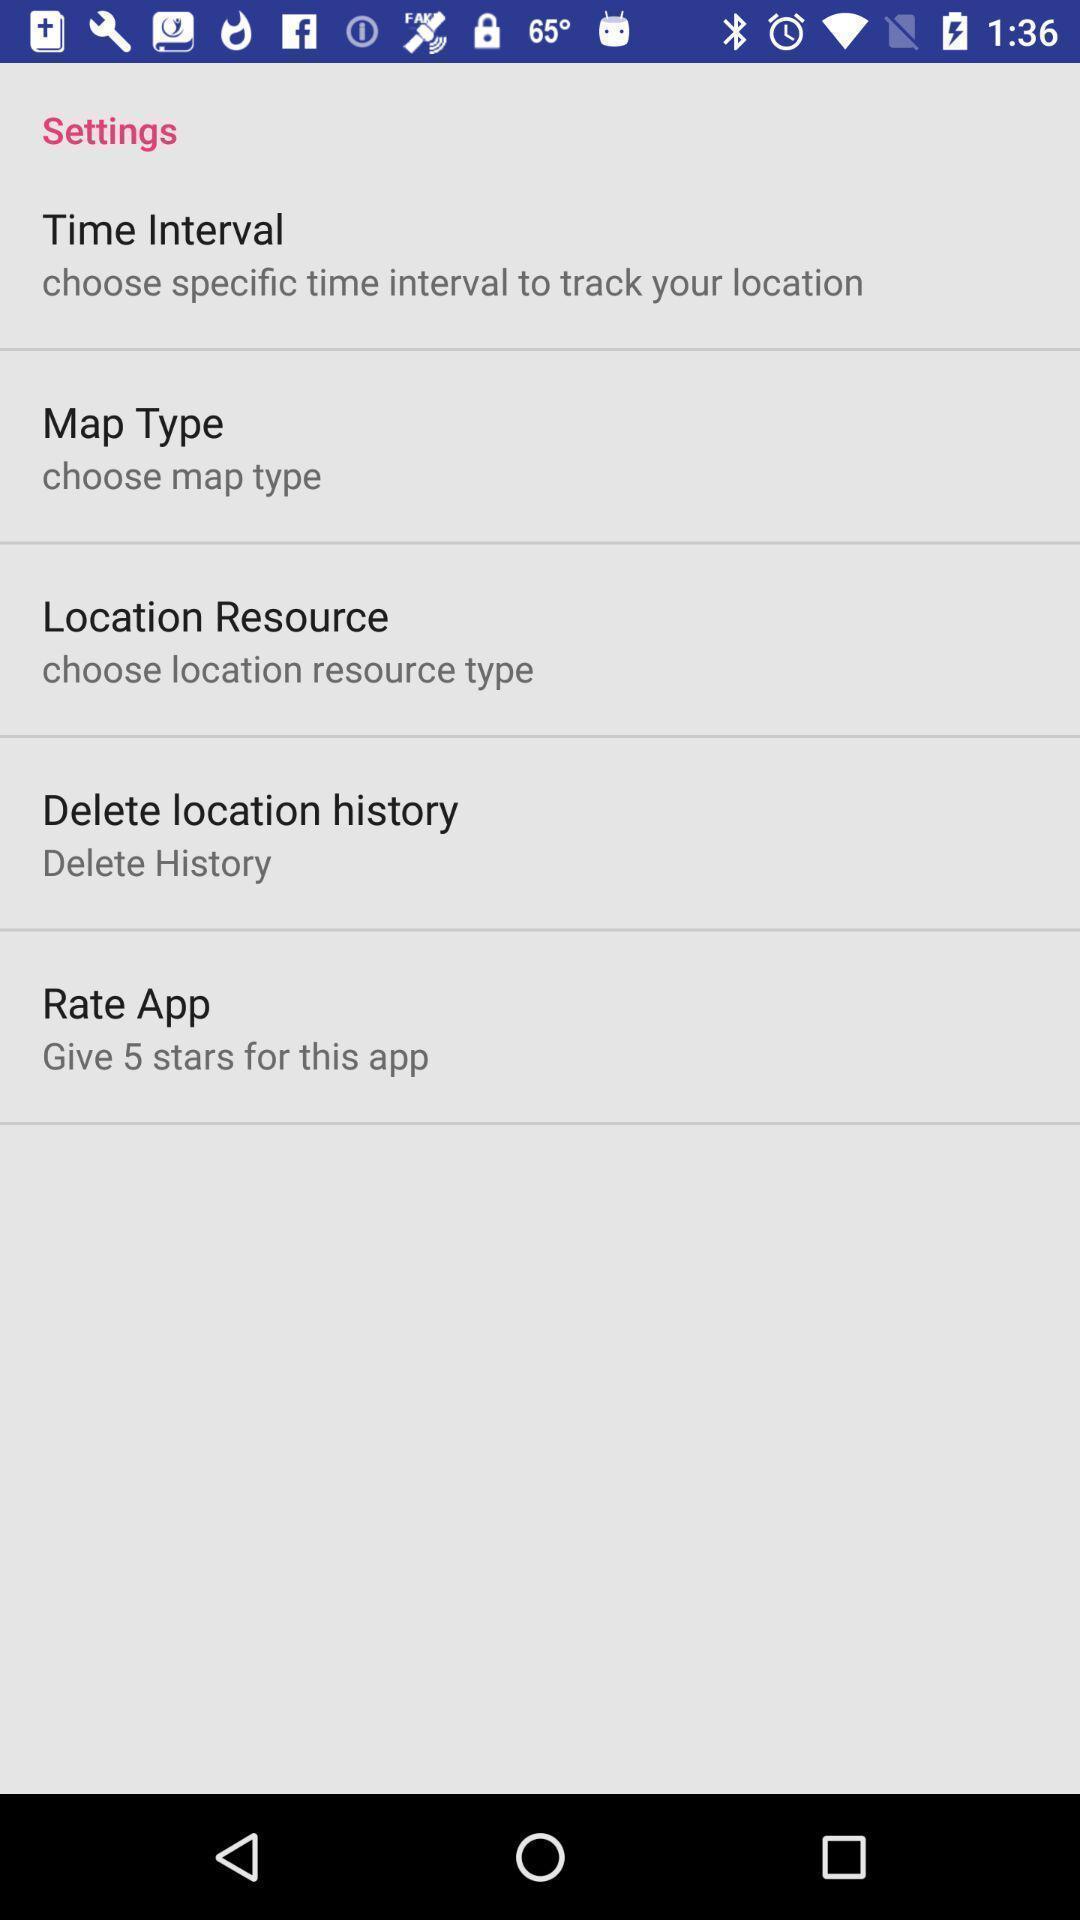Summarize the information in this screenshot. Settings page with multiple options. 